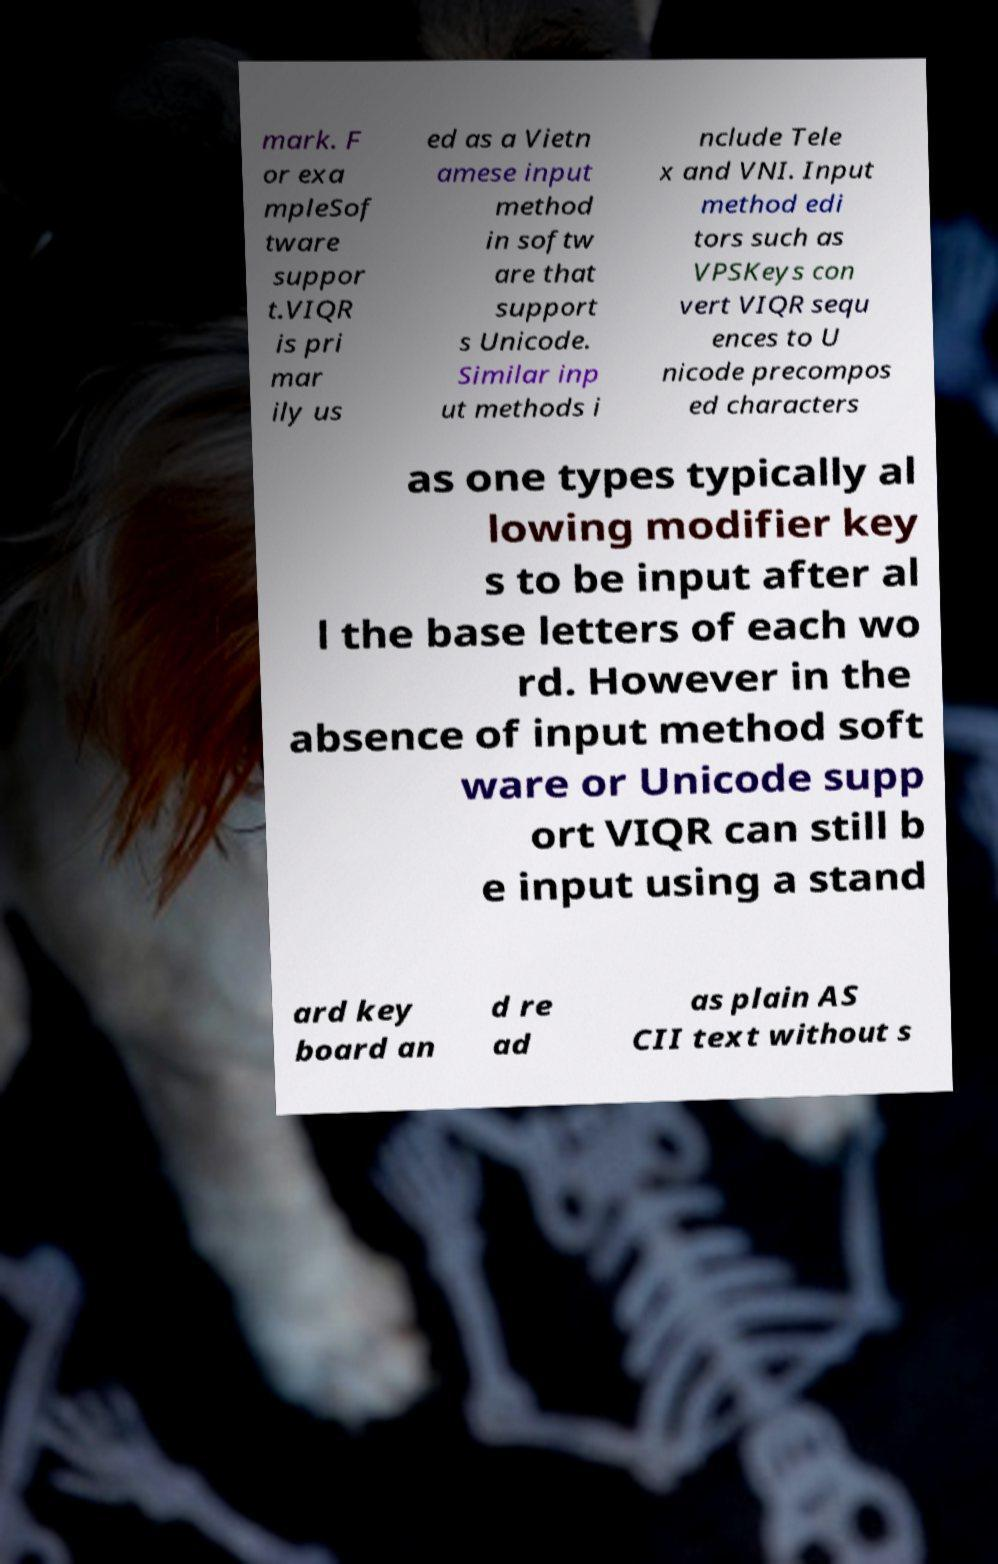Could you extract and type out the text from this image? mark. F or exa mpleSof tware suppor t.VIQR is pri mar ily us ed as a Vietn amese input method in softw are that support s Unicode. Similar inp ut methods i nclude Tele x and VNI. Input method edi tors such as VPSKeys con vert VIQR sequ ences to U nicode precompos ed characters as one types typically al lowing modifier key s to be input after al l the base letters of each wo rd. However in the absence of input method soft ware or Unicode supp ort VIQR can still b e input using a stand ard key board an d re ad as plain AS CII text without s 